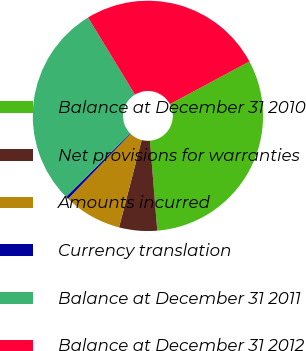<chart> <loc_0><loc_0><loc_500><loc_500><pie_chart><fcel>Balance at December 31 2010<fcel>Net provisions for warranties<fcel>Amounts incurred<fcel>Currency translation<fcel>Balance at December 31 2011<fcel>Balance at December 31 2012<nl><fcel>31.53%<fcel>5.33%<fcel>8.16%<fcel>0.4%<fcel>28.7%<fcel>25.87%<nl></chart> 